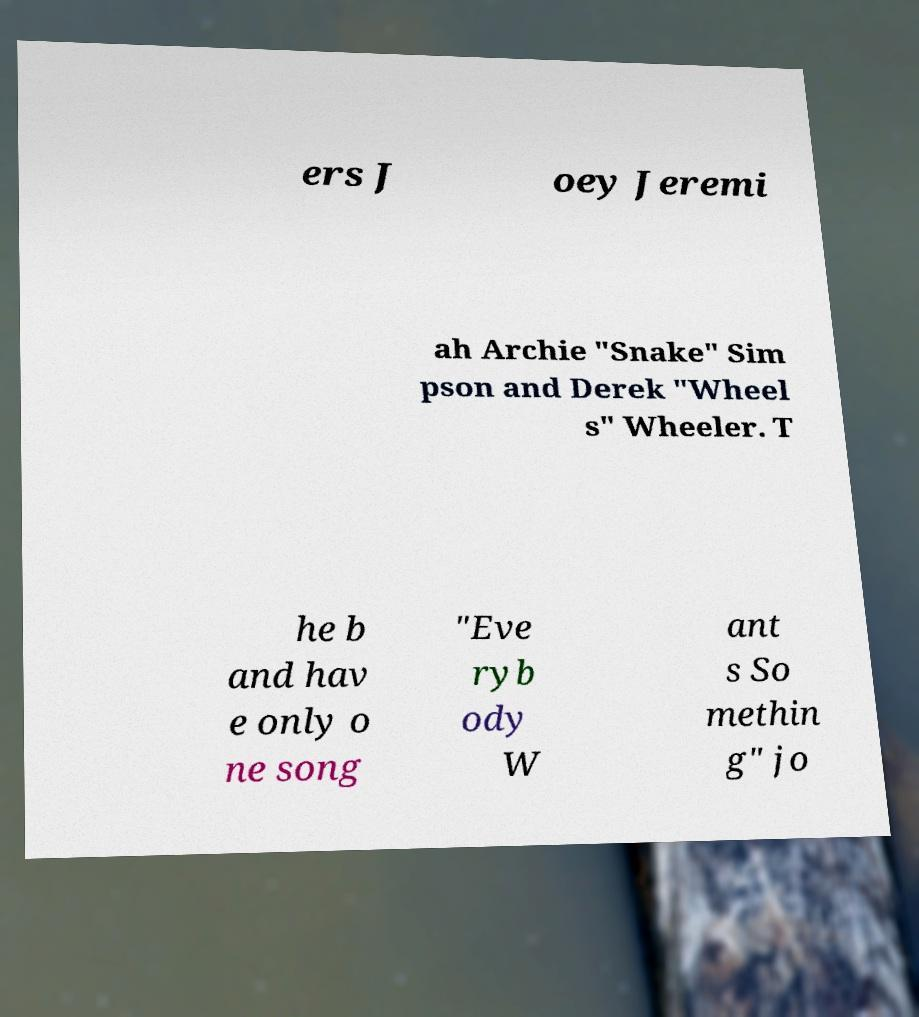There's text embedded in this image that I need extracted. Can you transcribe it verbatim? ers J oey Jeremi ah Archie "Snake" Sim pson and Derek "Wheel s" Wheeler. T he b and hav e only o ne song "Eve ryb ody W ant s So methin g" jo 